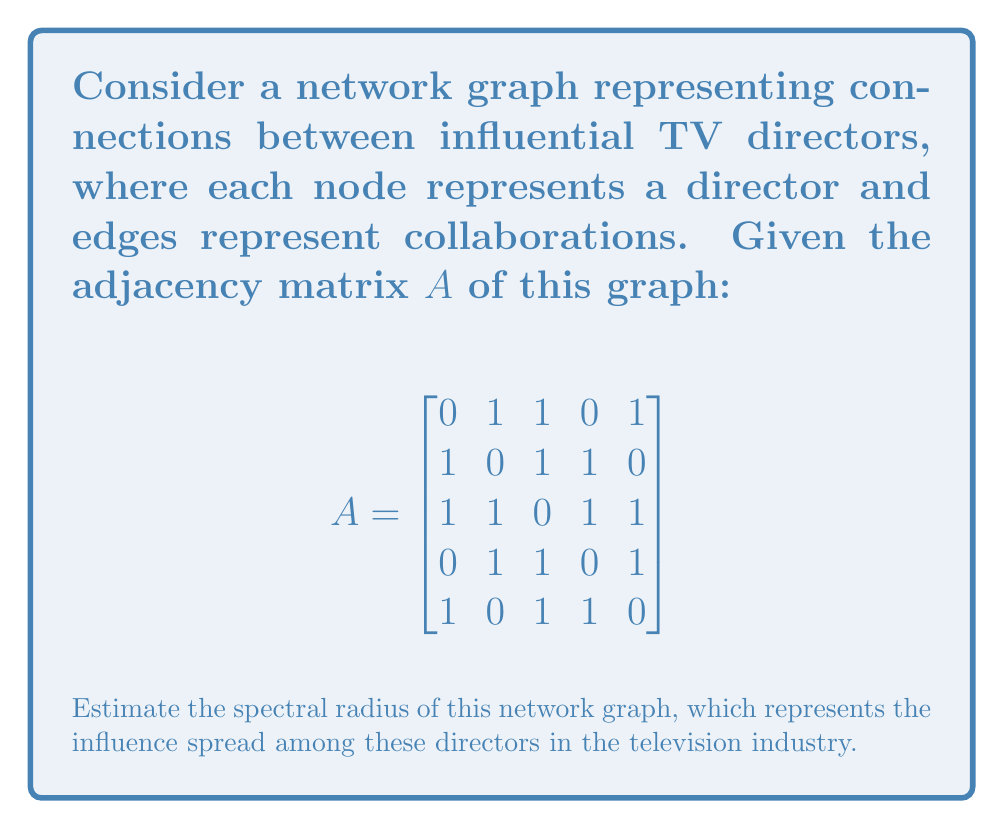Can you answer this question? To estimate the spectral radius of the network graph, we'll follow these steps:

1) The spectral radius is the largest absolute eigenvalue of the adjacency matrix $A$.

2) For a symmetric matrix like $A$, we can use the Power Method to estimate the largest eigenvalue.

3) Start with a random vector $v_0 = [1, 1, 1, 1, 1]^T$.

4) Iterate using the formula $v_{k+1} = \frac{Av_k}{\|Av_k\|}$ until convergence.

5) Let's perform a few iterations:

   Iteration 1:
   $Av_0 = [3, 3, 4, 3, 3]^T$
   $v_1 = \frac{1}{\sqrt{52}}[3, 3, 4, 3, 3]^T$

   Iteration 2:
   $Av_1 = \frac{1}{\sqrt{52}}[30, 30, 40, 30, 30]^T$
   $v_2 = \frac{1}{\sqrt{5200}}[30, 30, 40, 30, 30]^T$

   Iteration 3:
   $Av_2 = \frac{1}{\sqrt{5200}}[300, 300, 400, 300, 300]^T$
   $v_3 = \frac{1}{\sqrt{520000}}[300, 300, 400, 300, 300]^T$

6) The ratio of corresponding elements in consecutive iterations converges to the largest eigenvalue:

   $\lambda \approx \frac{300}{\frac{30}{\sqrt{10}}} = 10\sqrt{10} \approx 3.1623$

7) Therefore, the estimated spectral radius is approximately 3.1623.

This value represents the maximum influence spread rate in the network of TV directors, indicating how quickly ideas or collaborations can propagate through the network.
Answer: $3.1623$ 